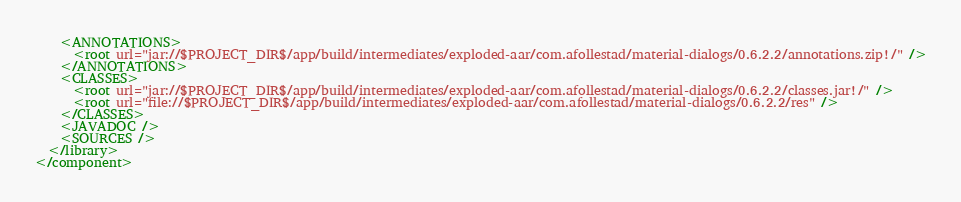<code> <loc_0><loc_0><loc_500><loc_500><_XML_>    <ANNOTATIONS>
      <root url="jar://$PROJECT_DIR$/app/build/intermediates/exploded-aar/com.afollestad/material-dialogs/0.6.2.2/annotations.zip!/" />
    </ANNOTATIONS>
    <CLASSES>
      <root url="jar://$PROJECT_DIR$/app/build/intermediates/exploded-aar/com.afollestad/material-dialogs/0.6.2.2/classes.jar!/" />
      <root url="file://$PROJECT_DIR$/app/build/intermediates/exploded-aar/com.afollestad/material-dialogs/0.6.2.2/res" />
    </CLASSES>
    <JAVADOC />
    <SOURCES />
  </library>
</component></code> 